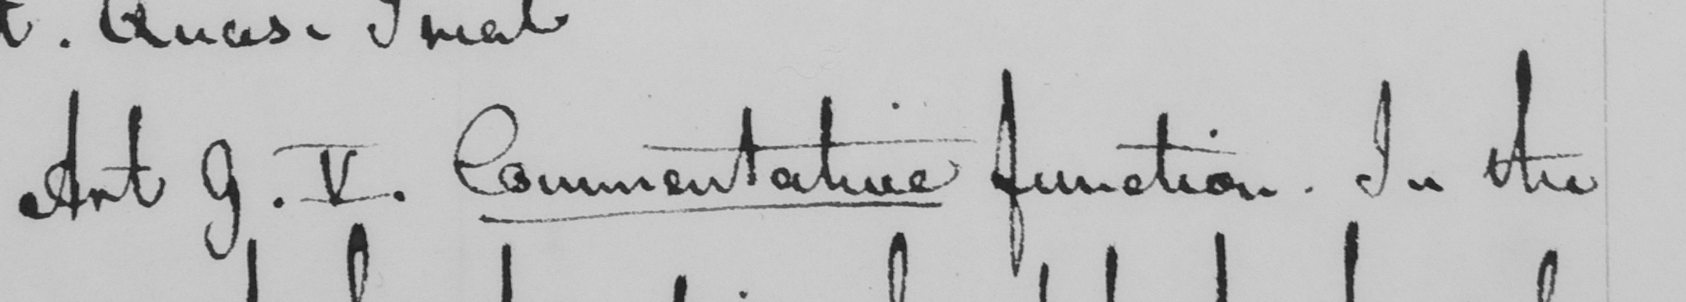Please provide the text content of this handwritten line. Art 9 . V . Commentative function . In the 